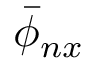<formula> <loc_0><loc_0><loc_500><loc_500>\bar { \phi } _ { n x }</formula> 